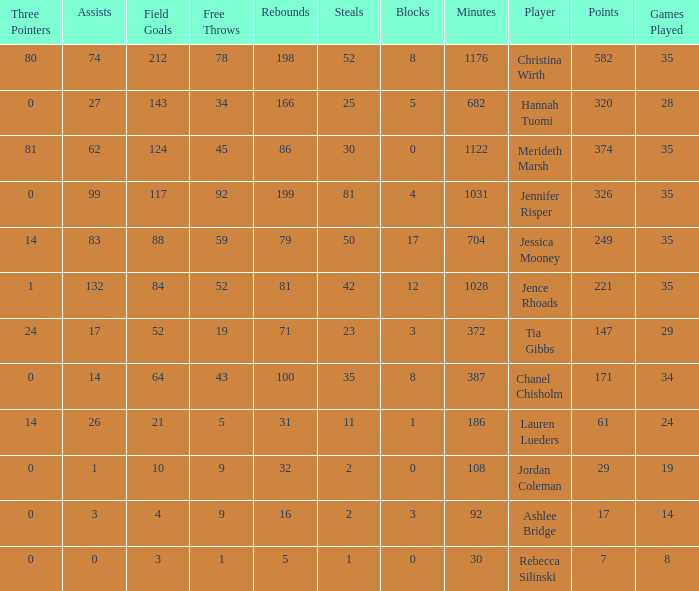What is the lowest number of 3 pointers that occured in games with 52 steals? 80.0. 